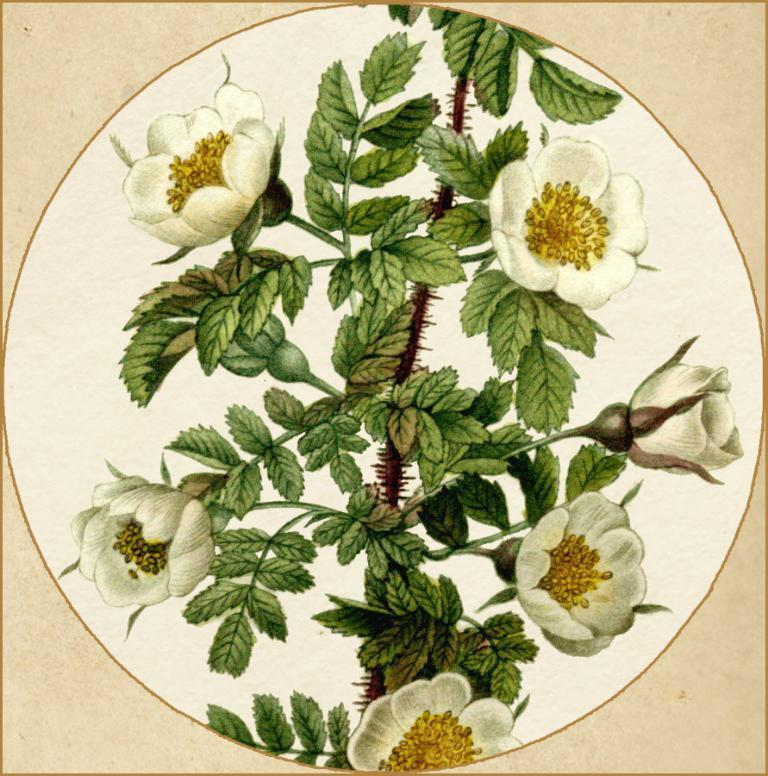What is depicted in the image? There is a painting of flowers in the image. How does the painting of flowers relate to the concept of education in the image? The image does not depict any connection between the painting of flowers and the concept of education. The image only features a painting of flowers, and there is no mention of education or any related context. 